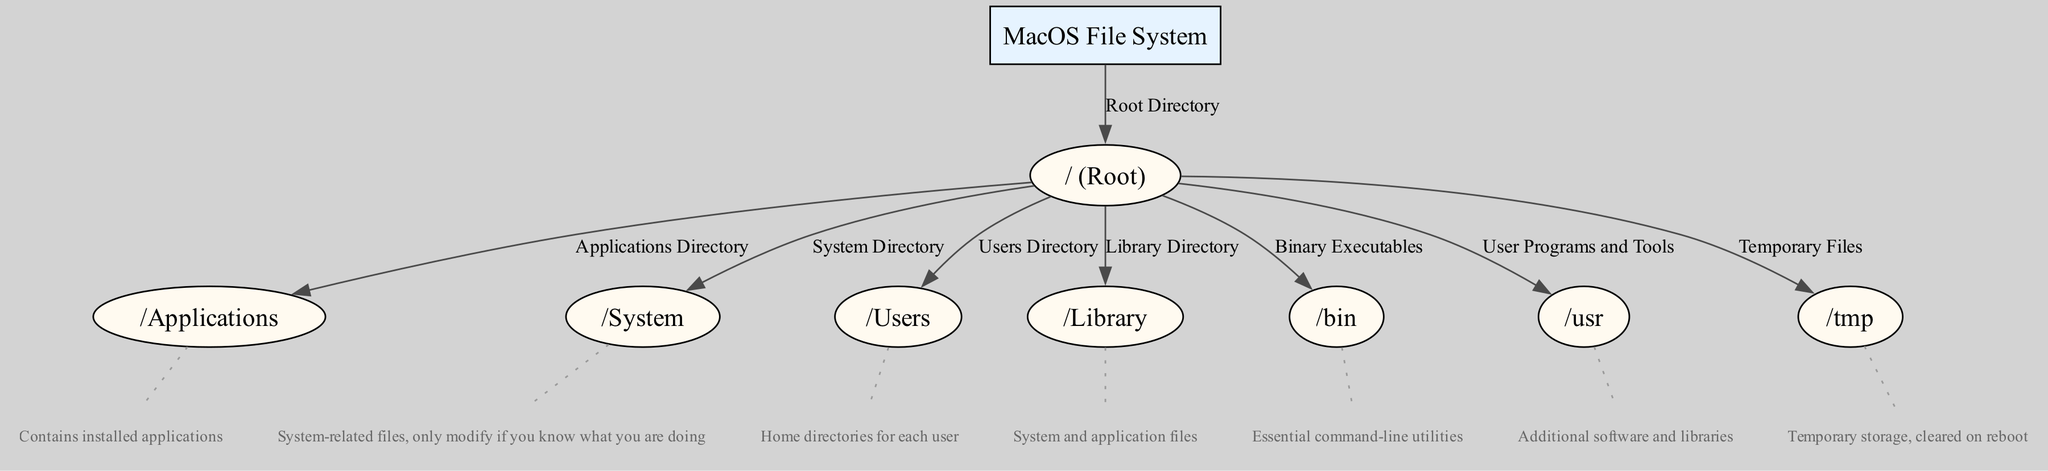What is the root directory of the MacOS file system? The diagram indicates that the root directory is represented as "/". It is the topmost level of the file system hierarchy in MacOS.
Answer: / How many primary directories are directly under the root directory? The diagram shows that there are five primary directories branching directly from the root directory, specifically Applications, System, Users, Library, and both binary and user program directories.
Answer: 5 What is contained in the "/Applications" directory? The description provided in the diagram states that "/Applications" contains installed applications. This is a standard location for software on MacOS.
Answer: Installed applications Which directory is designated for temporary files? The diagram clearly labels the "/tmp" directory as the location for temporary files, indicating its purpose within the file system hierarchy.
Answer: /tmp What type of files can be found in the "/System" directory? According to the diagram, the "/System" directory contains system-related files. It is important to note that modifications should only be made if one is familiar with the system's workings.
Answer: System-related files What type of files does the "/Library" directory store? The diagram describes that the "/Library" directory holds system and application files, making it essential for the functioning of the system and installed applications.
Answer: System and application files What does the "/usr" directory primarily include? The diagram indicates that the "/usr" directory is used for user programs and tools, which are additional software and libraries that are not essential to the system but can be very useful for users.
Answer: User programs and tools Which directory contains essential command-line utilities? The chart illustrates that the "/bin" directory is where essential command-line utilities are stored, which are critical for system operations and terminal commands.
Answer: /bin How are the edges labeled in this diagram? Each edge in the diagram is labeled to indicate the relationship between various directories and the root. These labels describe the nature of the connection, such as "Applications Directory" for the edge from root to Applications.
Answer: Directory relationships 